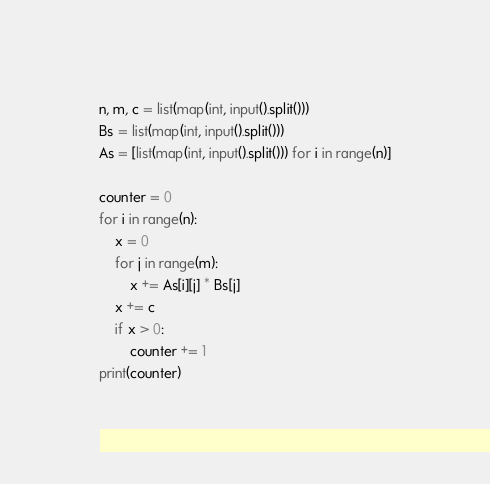<code> <loc_0><loc_0><loc_500><loc_500><_Python_>n, m, c = list(map(int, input().split()))
Bs = list(map(int, input().split()))
As = [list(map(int, input().split())) for i in range(n)]

counter = 0
for i in range(n):
    x = 0
    for j in range(m):
        x += As[i][j] * Bs[j]
    x += c
    if x > 0:
        counter += 1
print(counter)
</code> 